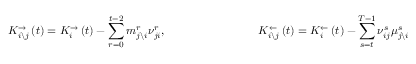Convert formula to latex. <formula><loc_0><loc_0><loc_500><loc_500>K _ { i \ j } ^ { \rightarrow } \left ( t \right ) = K _ { i } ^ { \rightarrow } \left ( t \right ) - \sum _ { r = 0 } ^ { t - 2 } m _ { j \ i } ^ { r } \nu _ { j i } ^ { r } , \quad K _ { i \ j } ^ { \leftarrow } \left ( t \right ) = K _ { i } ^ { \leftarrow } \left ( t \right ) - \sum _ { s = t } ^ { T - 1 } \nu _ { i j } ^ { s } \mu _ { j \ i } ^ { s }</formula> 